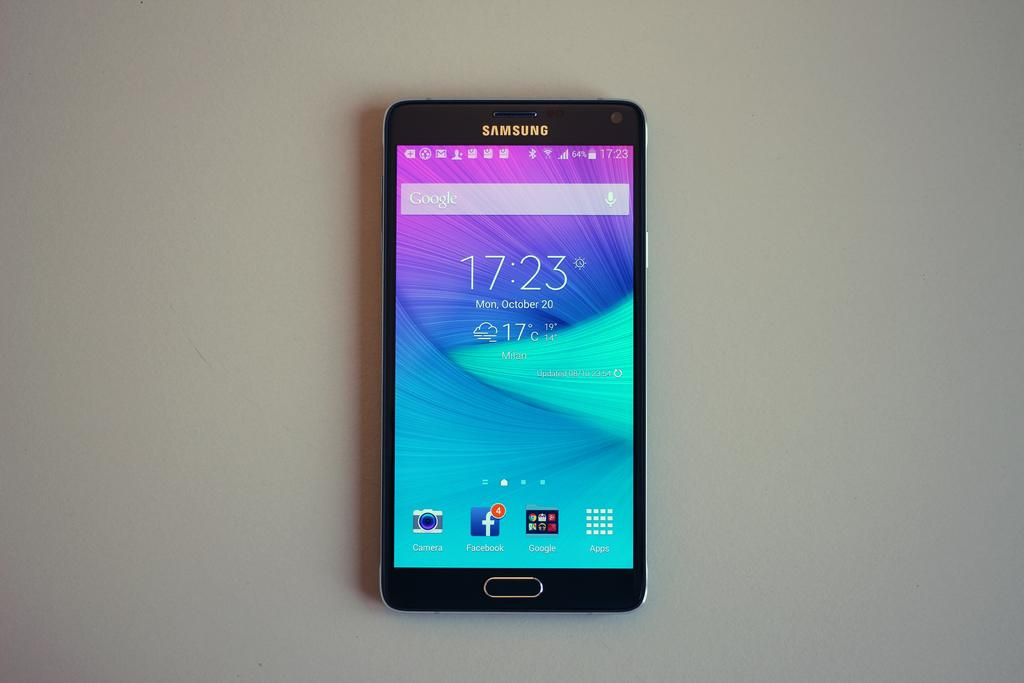<image>
Render a clear and concise summary of the photo. A black Samsung phone shows the time as 17:23. 